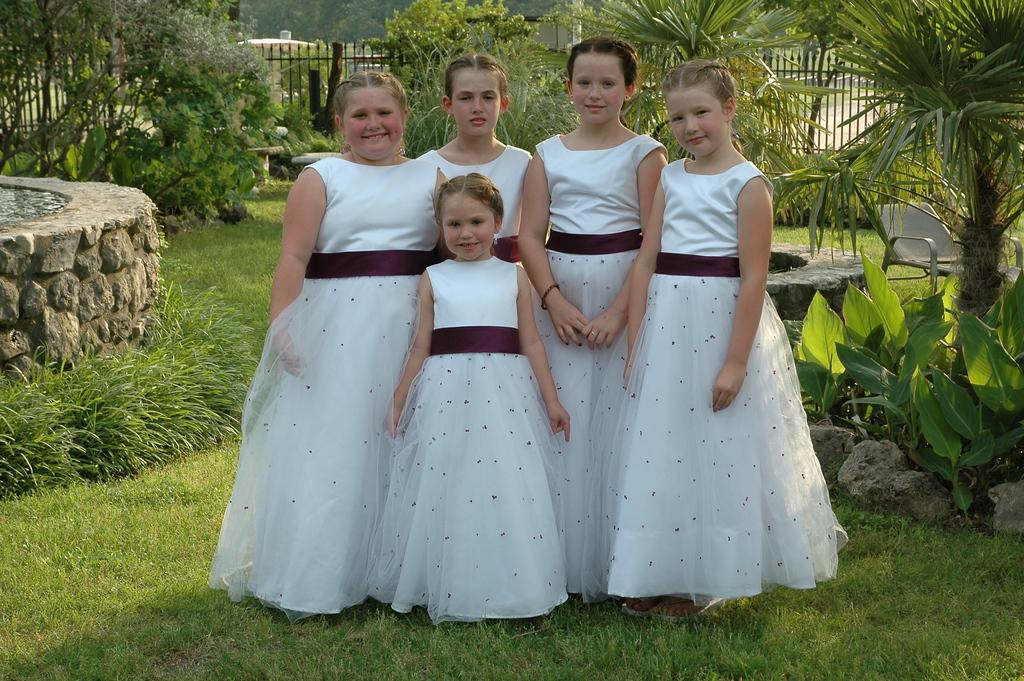What type of vegetation is present in the image? There is grass in the image. What are the people wearing in the image? The people are wearing white color dresses in the image. What other natural elements can be seen in the image? There are trees in the image. What type of barrier is visible in the image? There is a fence in the image. Can you tell me how many roses are in the hands of the people in the image? There are no roses present in the image; the people are wearing white dresses. What type of beverage is being served in the image? There is no beverage present in the image; it features grass, people wearing white dresses, trees, and a fence. 